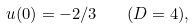Convert formula to latex. <formula><loc_0><loc_0><loc_500><loc_500>u ( 0 ) = - 2 / 3 \quad ( D = 4 ) ,</formula> 